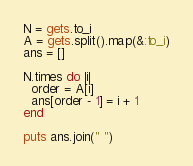<code> <loc_0><loc_0><loc_500><loc_500><_Ruby_>N = gets.to_i
A = gets.split().map(&:to_i)
ans = []

N.times do |i|
  order = A[i]
  ans[order - 1] = i + 1
end

puts ans.join(" ")</code> 